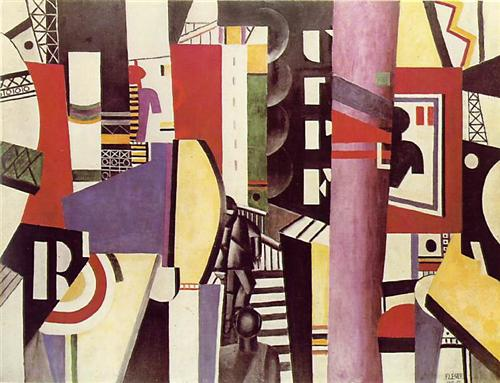Imagine if this artwork were a scene in a sci-fi movie. What could be happening in this scene? In a sci-fi movie, this artwork could represent a futuristic cityscape, bustling with advanced technology and vibrant life. The geometric shapes and contrasting colors might be the towering skyscrapers, neon signs, and sky bridges that weave through the city. Characters could be seen navigating this intricate maze of structures, possibly involved in high-speed chases or intense negotiations in hidden corners. The abstract forms might even represent holographic billboards or virtual reality spaces where people interact with digital versions of themselves. This dynamic and visually striking scene would set the stage for an epic narrative filled with suspense, innovation, and exploration. 